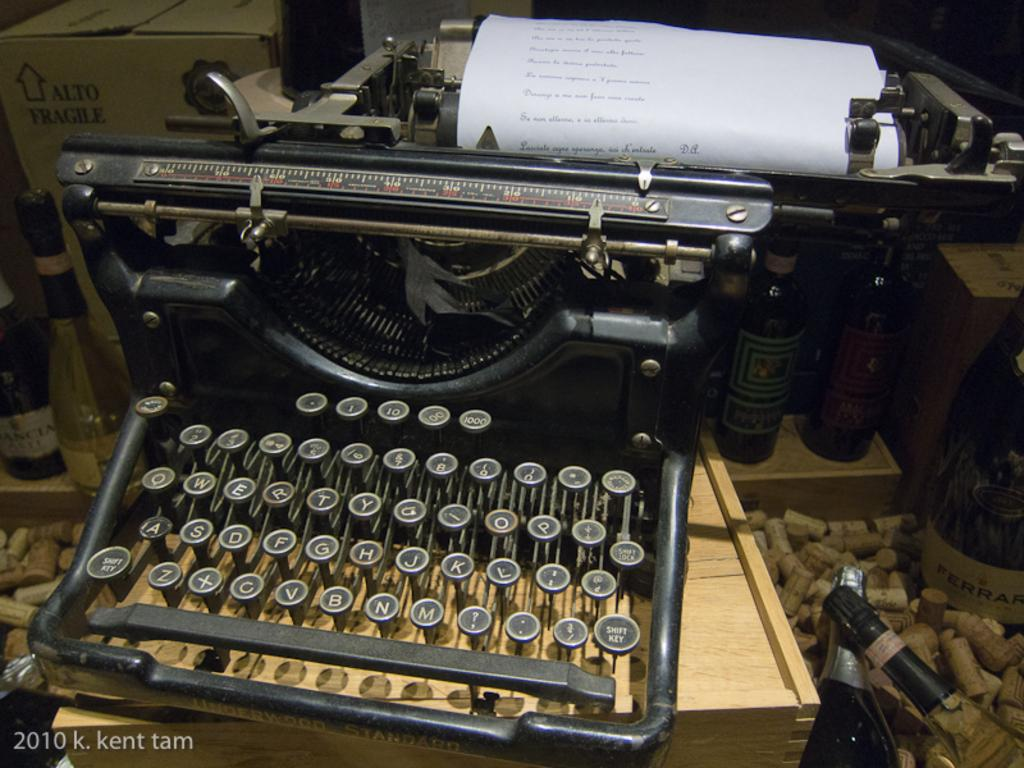What is the main object in the image? There is a black color typewriter in the image. What is placed on the typewriter? There is a paper on the typewriter. What else can be seen in the image besides the typewriter and paper? There is a box and bottles in the image. Can you describe what is written on the paper? Unfortunately, the specific content of what is written on the paper cannot be determined from the image. How many children are playing with the cat in the image? There are no children or cat present in the image. What time is displayed on the watch in the image? There is no watch present in the image. 